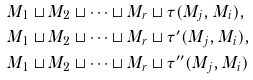Convert formula to latex. <formula><loc_0><loc_0><loc_500><loc_500>& M _ { 1 } \sqcup M _ { 2 } \sqcup \cdots \sqcup M _ { r } \sqcup \tau ( M _ { j } , M _ { i } ) , \\ & M _ { 1 } \sqcup M _ { 2 } \sqcup \cdots \sqcup M _ { r } \sqcup \tau ^ { \prime } ( M _ { j } , M _ { i } ) , \\ & M _ { 1 } \sqcup M _ { 2 } \sqcup \cdots \sqcup M _ { r } \sqcup \tau ^ { \prime \prime } ( M _ { j } , M _ { i } )</formula> 